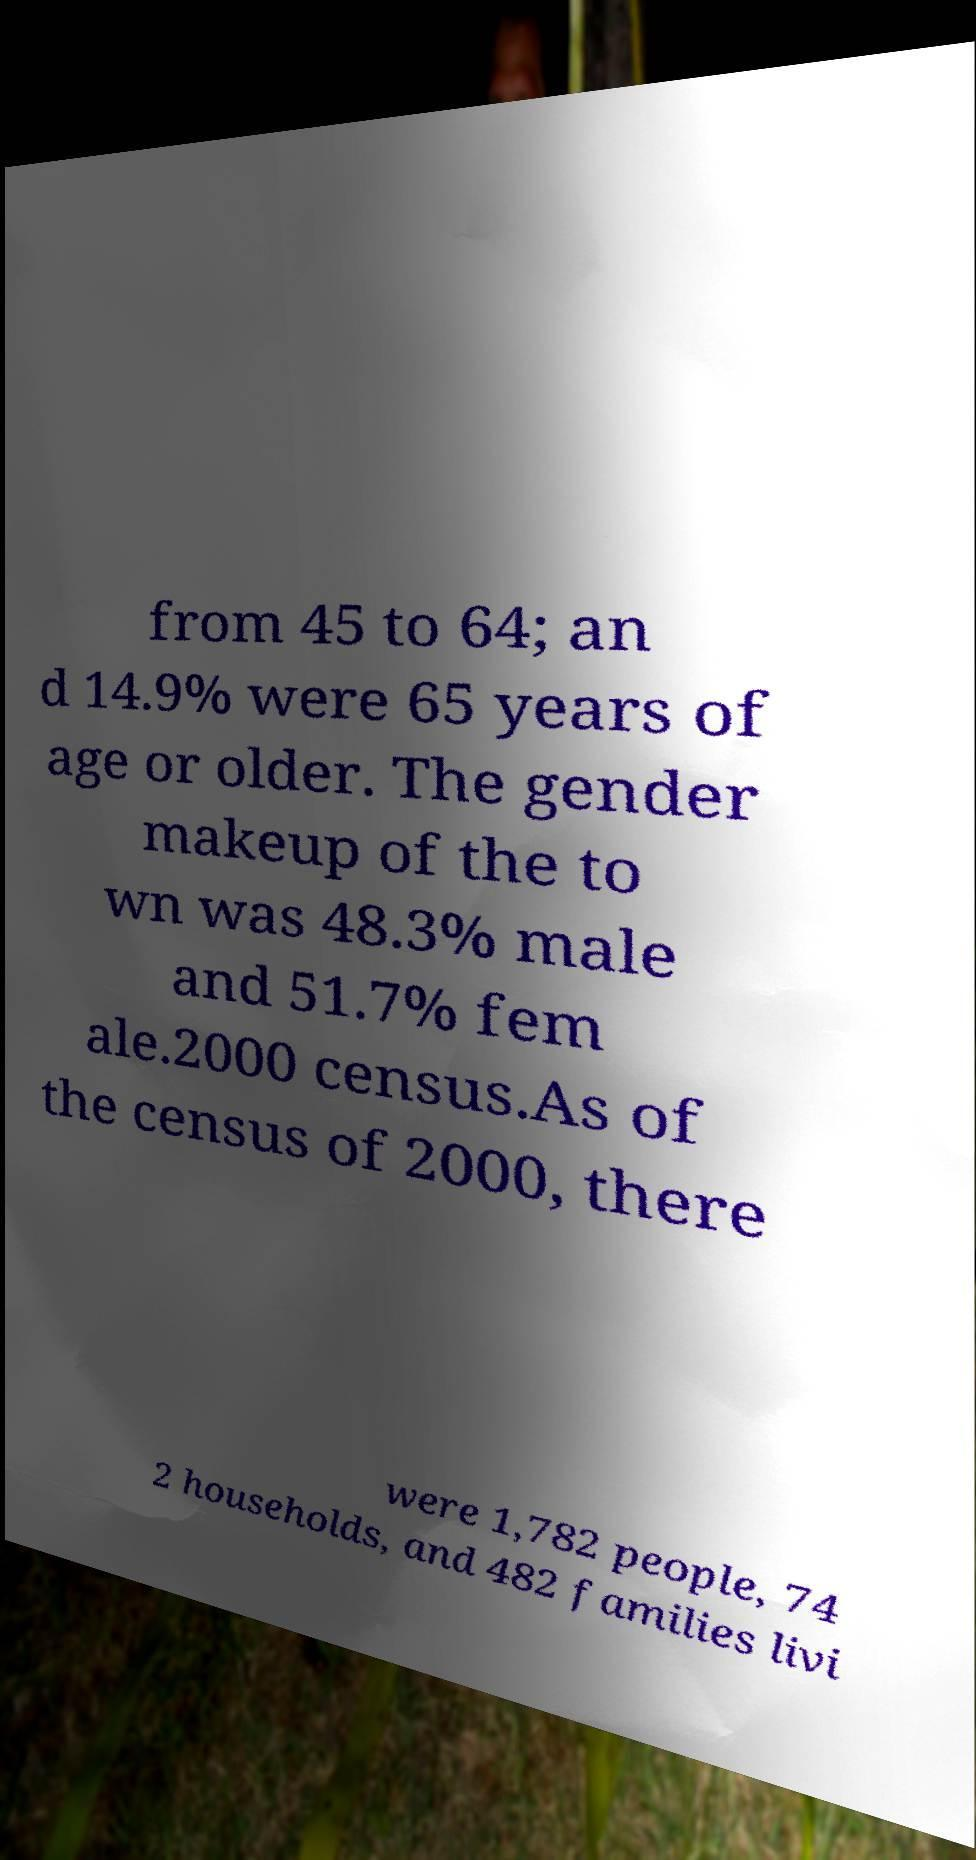Please identify and transcribe the text found in this image. from 45 to 64; an d 14.9% were 65 years of age or older. The gender makeup of the to wn was 48.3% male and 51.7% fem ale.2000 census.As of the census of 2000, there were 1,782 people, 74 2 households, and 482 families livi 